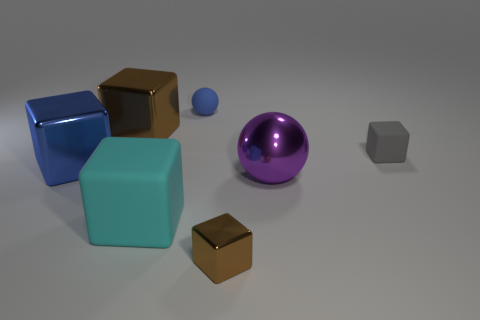There is a brown thing that is left of the blue matte thing to the left of the large purple metal thing; what is its shape?
Your answer should be very brief. Cube. There is a big cube that is the same color as the matte ball; what material is it?
Your answer should be very brief. Metal. The small object that is made of the same material as the small blue sphere is what color?
Make the answer very short. Gray. Is there anything else that is the same size as the gray block?
Offer a terse response. Yes. There is a metal cube that is in front of the big blue metal block; is it the same color as the block on the left side of the big brown metal thing?
Your response must be concise. No. Is the number of blue rubber spheres to the right of the purple metallic object greater than the number of small brown things behind the blue metal cube?
Offer a terse response. No. The other small object that is the same shape as the purple object is what color?
Ensure brevity in your answer.  Blue. Is there anything else that is the same shape as the big cyan object?
Offer a very short reply. Yes. There is a big cyan rubber thing; is it the same shape as the large metal object that is behind the large blue metal thing?
Ensure brevity in your answer.  Yes. What number of other things are the same material as the blue block?
Your response must be concise. 3. 